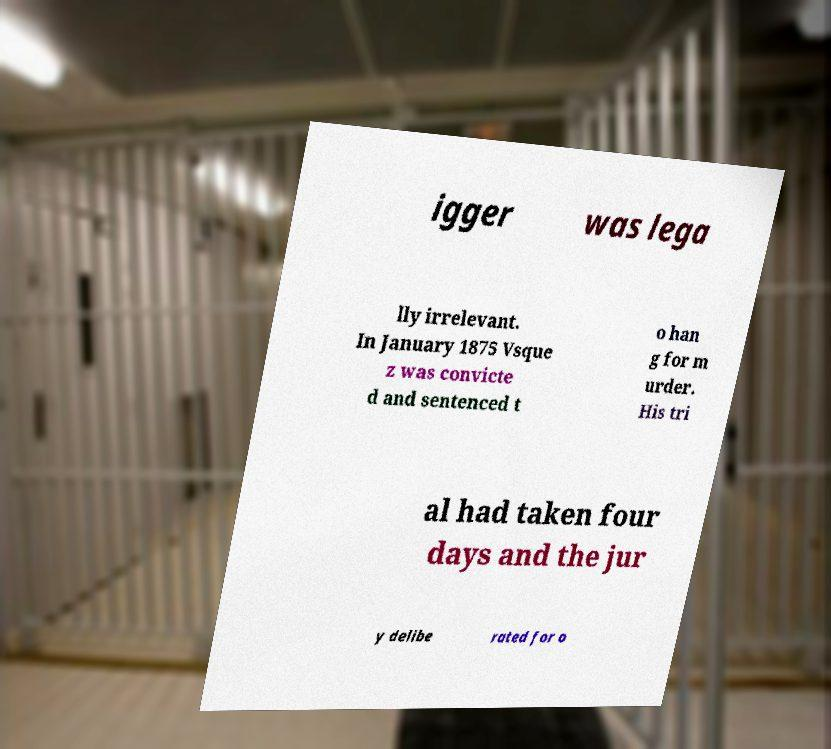Could you assist in decoding the text presented in this image and type it out clearly? igger was lega lly irrelevant. In January 1875 Vsque z was convicte d and sentenced t o han g for m urder. His tri al had taken four days and the jur y delibe rated for o 